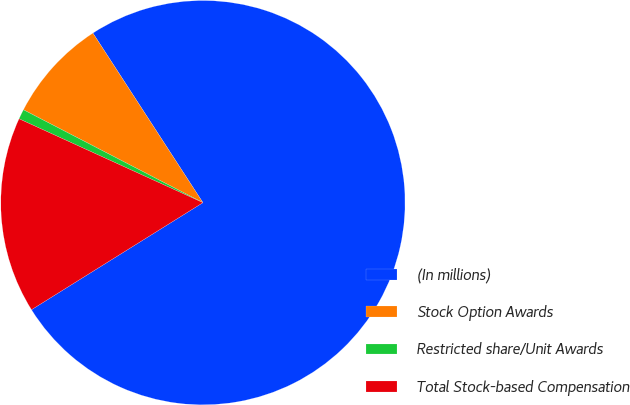Convert chart. <chart><loc_0><loc_0><loc_500><loc_500><pie_chart><fcel>(In millions)<fcel>Stock Option Awards<fcel>Restricted share/Unit Awards<fcel>Total Stock-based Compensation<nl><fcel>75.27%<fcel>8.24%<fcel>0.79%<fcel>15.69%<nl></chart> 